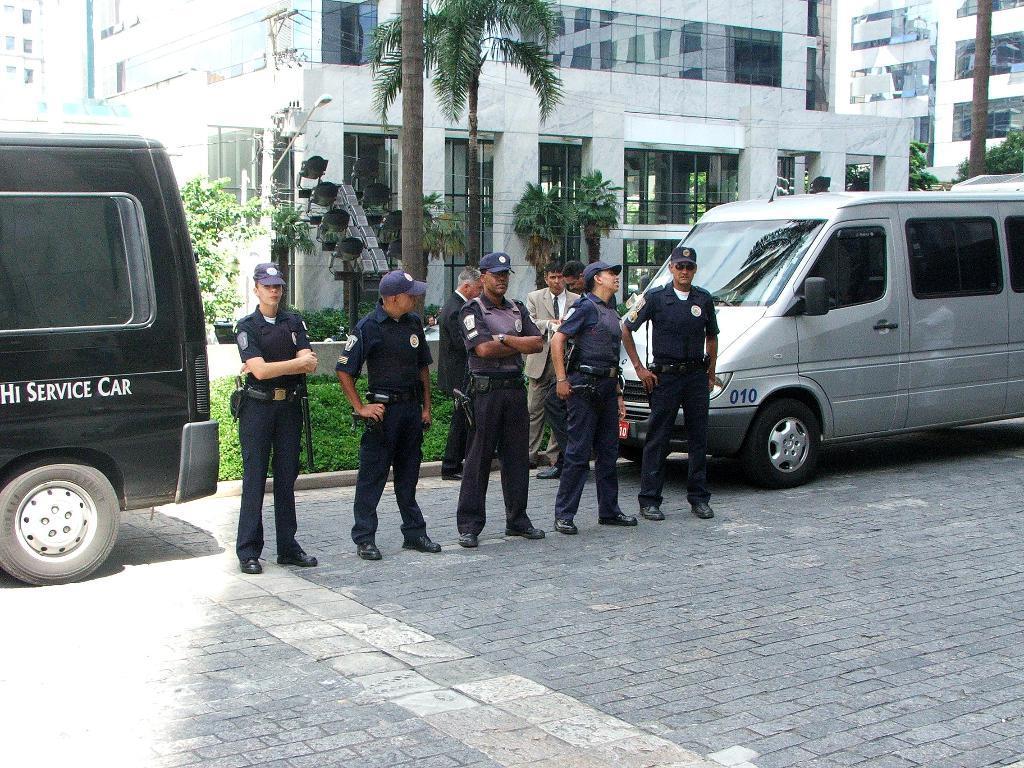Please provide a concise description of this image. This is the outside view of a building, here we can see some persons standing on the road all are wearing their shoes and caps. Here we can see the vehicles on the road. And on the background there are buildings even we can see plants and trees. 